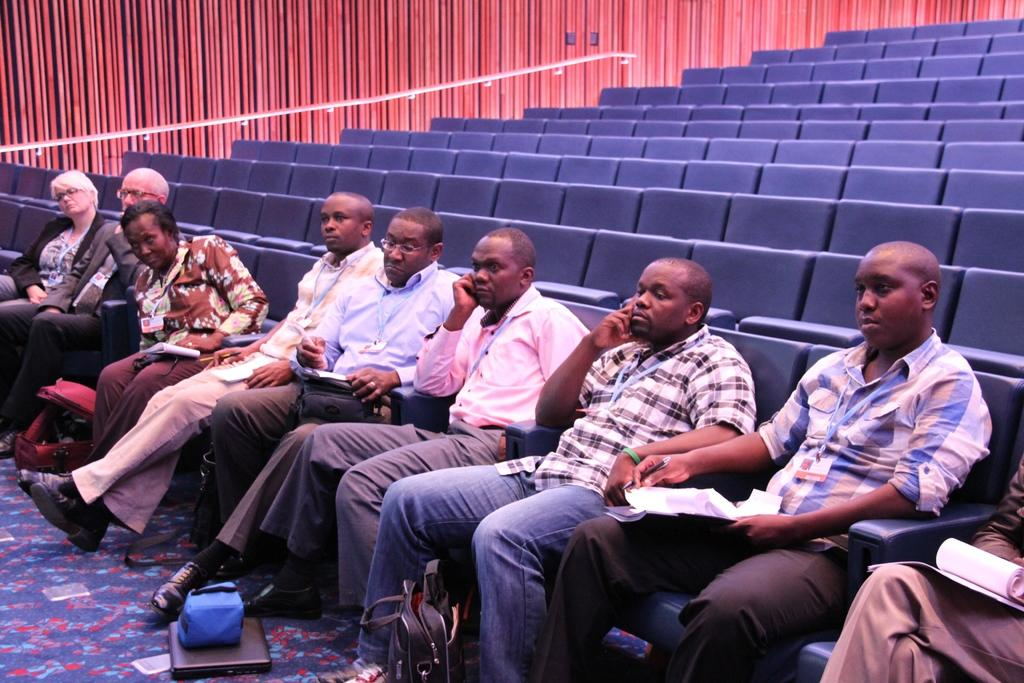What are the people in the image doing? The people in the image are sitting on chairs. Are the people holding anything? Yes, some of the people are holding objects. What can be seen in the background of the image? There are chairs, bags, and other objects on the floor in the background of the image. Can you tell me how many times the calculator is used in the image? There is no calculator present in the image, so it cannot be determined how many times it is used. 